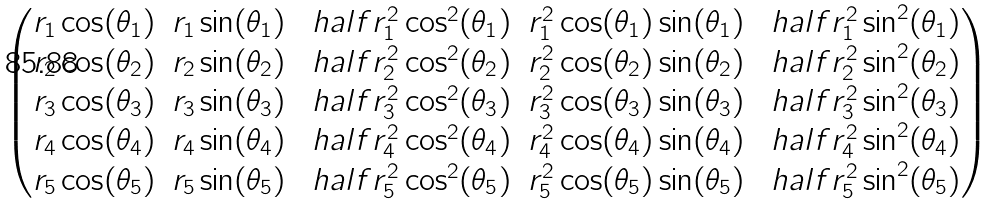Convert formula to latex. <formula><loc_0><loc_0><loc_500><loc_500>\begin{pmatrix} r _ { 1 } \cos ( \theta _ { 1 } ) & r _ { 1 } \sin ( \theta _ { 1 } ) & \ h a l f r _ { 1 } ^ { 2 } \cos ^ { 2 } ( \theta _ { 1 } ) & r _ { 1 } ^ { 2 } \cos ( \theta _ { 1 } ) \sin ( \theta _ { 1 } ) & \ h a l f r _ { 1 } ^ { 2 } \sin ^ { 2 } ( \theta _ { 1 } ) \\ r _ { 2 } \cos ( \theta _ { 2 } ) & r _ { 2 } \sin ( \theta _ { 2 } ) & \ h a l f r _ { 2 } ^ { 2 } \cos ^ { 2 } ( \theta _ { 2 } ) & r _ { 2 } ^ { 2 } \cos ( \theta _ { 2 } ) \sin ( \theta _ { 2 } ) & \ h a l f r _ { 2 } ^ { 2 } \sin ^ { 2 } ( \theta _ { 2 } ) \\ r _ { 3 } \cos ( \theta _ { 3 } ) & r _ { 3 } \sin ( \theta _ { 3 } ) & \ h a l f r _ { 3 } ^ { 2 } \cos ^ { 2 } ( \theta _ { 3 } ) & r _ { 3 } ^ { 2 } \cos ( \theta _ { 3 } ) \sin ( \theta _ { 3 } ) & \ h a l f r _ { 3 } ^ { 2 } \sin ^ { 2 } ( \theta _ { 3 } ) \\ r _ { 4 } \cos ( \theta _ { 4 } ) & r _ { 4 } \sin ( \theta _ { 4 } ) & \ h a l f r _ { 4 } ^ { 2 } \cos ^ { 2 } ( \theta _ { 4 } ) & r _ { 4 } ^ { 2 } \cos ( \theta _ { 4 } ) \sin ( \theta _ { 4 } ) & \ h a l f r _ { 4 } ^ { 2 } \sin ^ { 2 } ( \theta _ { 4 } ) \\ r _ { 5 } \cos ( \theta _ { 5 } ) & r _ { 5 } \sin ( \theta _ { 5 } ) & \ h a l f r _ { 5 } ^ { 2 } \cos ^ { 2 } ( \theta _ { 5 } ) & r _ { 5 } ^ { 2 } \cos ( \theta _ { 5 } ) \sin ( \theta _ { 5 } ) & \ h a l f r _ { 5 } ^ { 2 } \sin ^ { 2 } ( \theta _ { 5 } ) \end{pmatrix}</formula> 